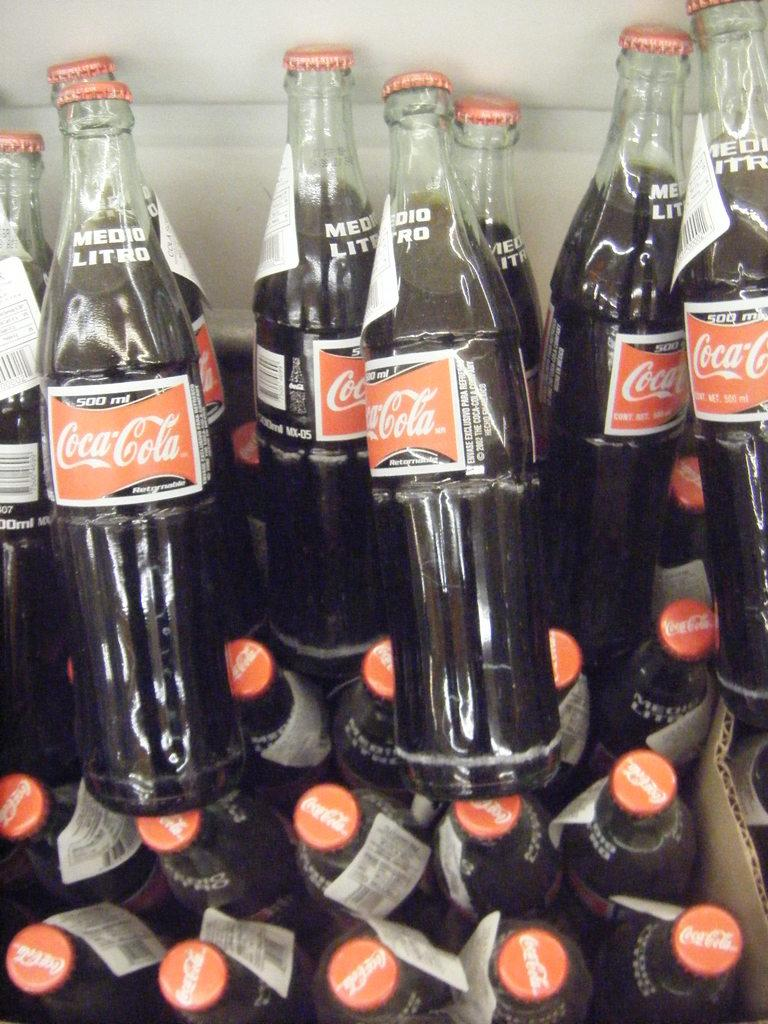<image>
Describe the image concisely. Several old style bottle of coco-cola with red tops. 